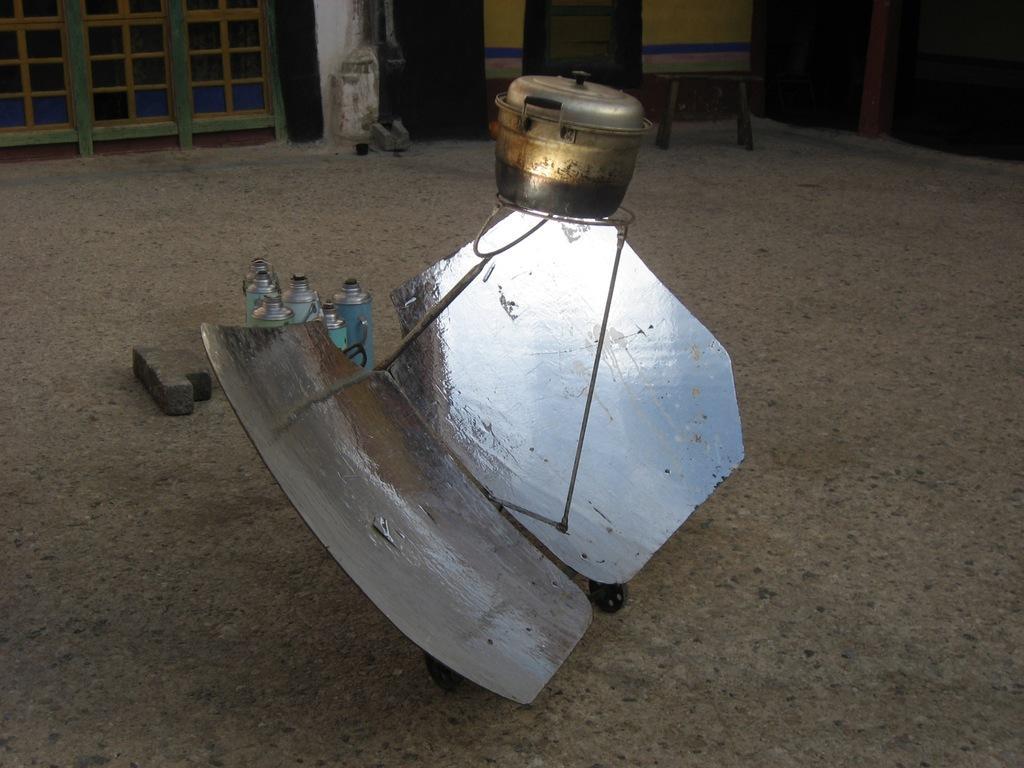Please provide a concise description of this image. In the center of the picture there are bottles, brick and an iron object. At the top there are windows, stool and other wooden objects. 